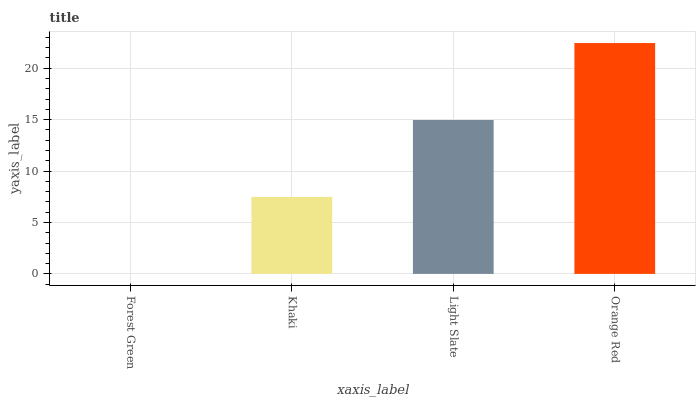Is Forest Green the minimum?
Answer yes or no. Yes. Is Orange Red the maximum?
Answer yes or no. Yes. Is Khaki the minimum?
Answer yes or no. No. Is Khaki the maximum?
Answer yes or no. No. Is Khaki greater than Forest Green?
Answer yes or no. Yes. Is Forest Green less than Khaki?
Answer yes or no. Yes. Is Forest Green greater than Khaki?
Answer yes or no. No. Is Khaki less than Forest Green?
Answer yes or no. No. Is Light Slate the high median?
Answer yes or no. Yes. Is Khaki the low median?
Answer yes or no. Yes. Is Orange Red the high median?
Answer yes or no. No. Is Light Slate the low median?
Answer yes or no. No. 